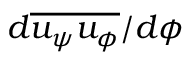<formula> <loc_0><loc_0><loc_500><loc_500>d \overline { { u _ { \psi } u _ { \phi } } } / d \phi</formula> 